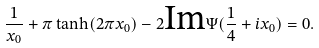<formula> <loc_0><loc_0><loc_500><loc_500>\frac { 1 } { x _ { 0 } } + \pi \tanh ( 2 \pi x _ { 0 } ) - 2 \text {Im} \Psi ( \frac { 1 } { 4 } + i x _ { 0 } ) = 0 .</formula> 